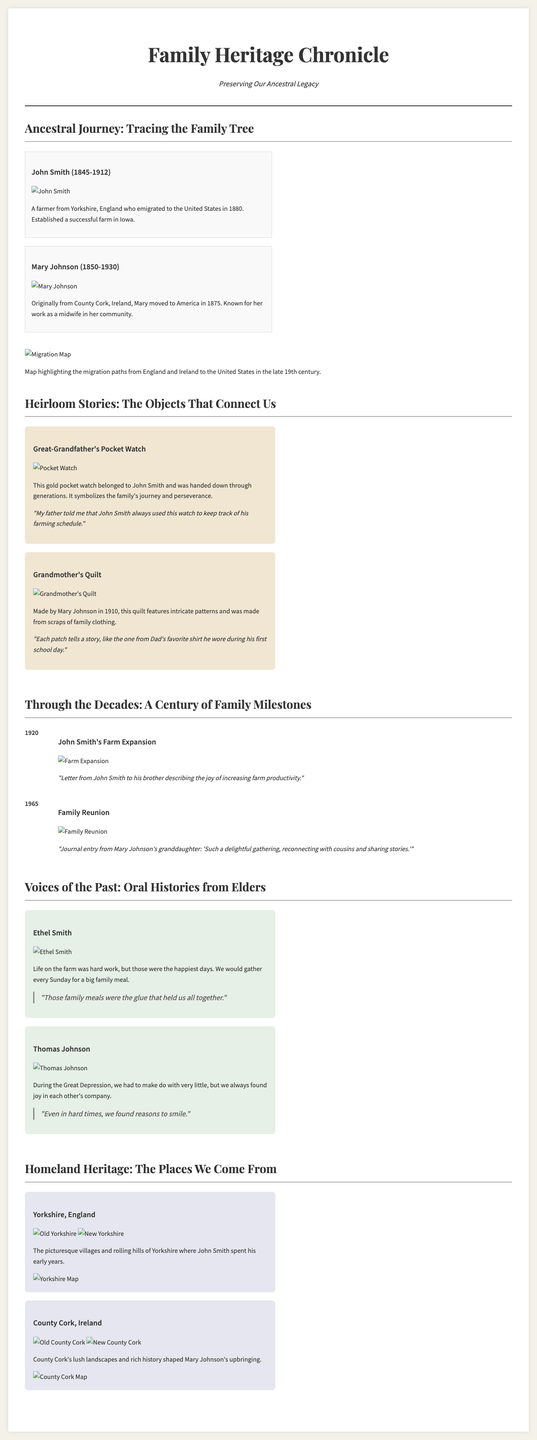What years did John Smith live? John Smith's lifespan is detailed in the biographical information, indicating he lived from 1845 to 1912.
Answer: 1845-1912 Who made the quilt? The document mentions that the quilt was made by Mary Johnson in 1910, as stated in the heirloom stories.
Answer: Mary Johnson What significant family event occurred in 1965? The timeline section highlights that a family reunion occurred in 1965, providing context to family gatherings.
Answer: Family Reunion What item belonged to John Smith? The section on heirloom stories clearly indicates that the pocket watch belonged to John Smith, linking it to family history.
Answer: Pocket Watch What is one quote from Ethel Smith? Ethel Smith's oral history includes the quote about family meals being crucial to family bonds.
Answer: "Those family meals were the glue that held us all together." Which county is Mary Johnson from? The ancestral journey information states that Mary Johnson was originally from County Cork, Ireland, establishing her heritage.
Answer: County Cork In which country is Yorkshire located? The document emphasizes Yorkshire in the context of John Smith, identifying it as a location in England.
Answer: England What type of card features the heirlooms? The layout specifies that heirloom stories are presented in heirloom cards, showcasing treasured family objects.
Answer: Heirloom Card 